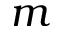Convert formula to latex. <formula><loc_0><loc_0><loc_500><loc_500>m</formula> 